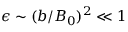Convert formula to latex. <formula><loc_0><loc_0><loc_500><loc_500>\epsilon \sim ( b / B _ { 0 } ) ^ { 2 } \ll 1</formula> 